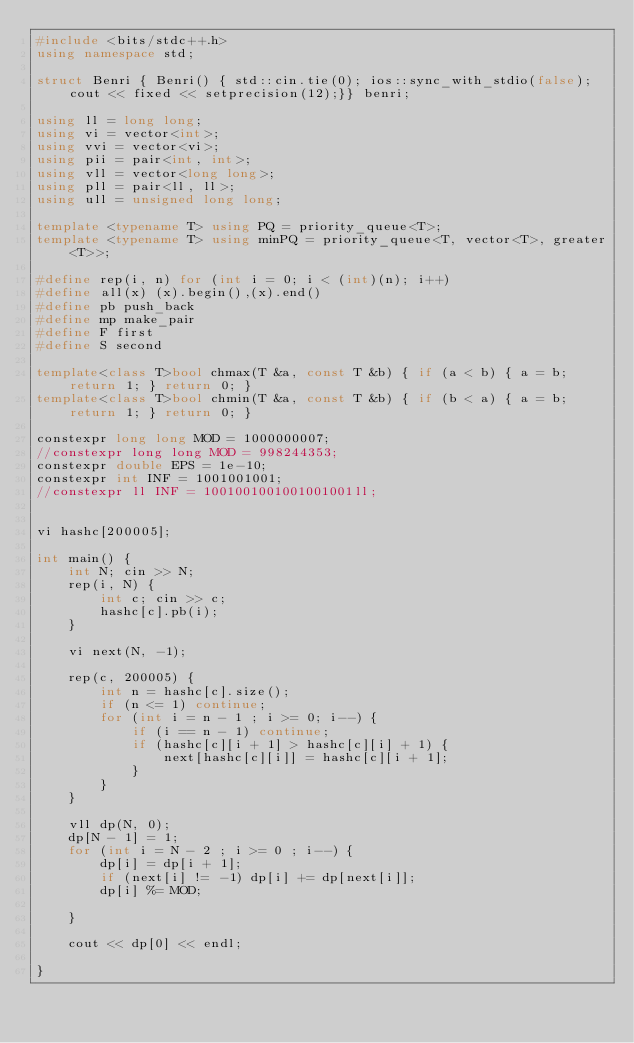Convert code to text. <code><loc_0><loc_0><loc_500><loc_500><_C++_>#include <bits/stdc++.h>
using namespace std;

struct Benri { Benri() { std::cin.tie(0); ios::sync_with_stdio(false); cout << fixed << setprecision(12);}} benri;

using ll = long long;
using vi = vector<int>;
using vvi = vector<vi>;
using pii = pair<int, int>;
using vll = vector<long long>;
using pll = pair<ll, ll>;
using ull = unsigned long long;

template <typename T> using PQ = priority_queue<T>;
template <typename T> using minPQ = priority_queue<T, vector<T>, greater<T>>;

#define rep(i, n) for (int i = 0; i < (int)(n); i++)
#define all(x) (x).begin(),(x).end()
#define pb push_back
#define mp make_pair
#define F first
#define S second

template<class T>bool chmax(T &a, const T &b) { if (a < b) { a = b; return 1; } return 0; }
template<class T>bool chmin(T &a, const T &b) { if (b < a) { a = b; return 1; } return 0; }

constexpr long long MOD = 1000000007;
//constexpr long long MOD = 998244353;
constexpr double EPS = 1e-10;
constexpr int INF = 1001001001;
//constexpr ll INF = 1001001001001001001ll;


vi hashc[200005];

int main() {
    int N; cin >> N;
    rep(i, N) {
        int c; cin >> c;
        hashc[c].pb(i);
    }

    vi next(N, -1);

    rep(c, 200005) {
        int n = hashc[c].size();
        if (n <= 1) continue;
        for (int i = n - 1 ; i >= 0; i--) {
            if (i == n - 1) continue;
            if (hashc[c][i + 1] > hashc[c][i] + 1) {
                next[hashc[c][i]] = hashc[c][i + 1];
            }
        }
    }

    vll dp(N, 0);
    dp[N - 1] = 1;
    for (int i = N - 2 ; i >= 0 ; i--) {
        dp[i] = dp[i + 1];
        if (next[i] != -1) dp[i] += dp[next[i]];
        dp[i] %= MOD;

    }

    cout << dp[0] << endl;

}</code> 